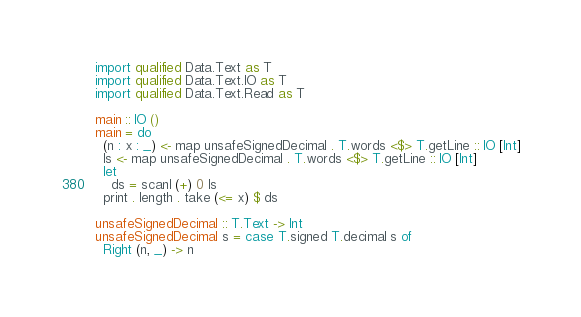<code> <loc_0><loc_0><loc_500><loc_500><_Haskell_>import qualified Data.Text as T
import qualified Data.Text.IO as T
import qualified Data.Text.Read as T

main :: IO ()
main = do
  (n : x : _) <- map unsafeSignedDecimal . T.words <$> T.getLine :: IO [Int]
  ls <- map unsafeSignedDecimal . T.words <$> T.getLine :: IO [Int]
  let
    ds = scanl (+) 0 ls
  print . length . take (<= x) $ ds

unsafeSignedDecimal :: T.Text -> Int
unsafeSignedDecimal s = case T.signed T.decimal s of
  Right (n, _) -> n
</code> 